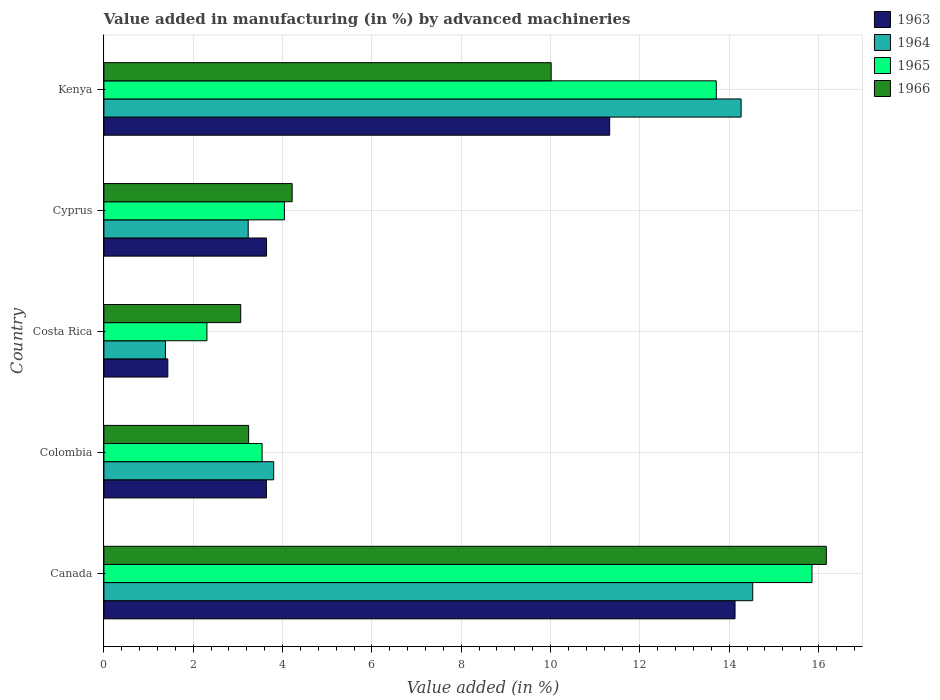How many different coloured bars are there?
Provide a short and direct response. 4. How many groups of bars are there?
Ensure brevity in your answer.  5. Are the number of bars on each tick of the Y-axis equal?
Provide a short and direct response. Yes. How many bars are there on the 3rd tick from the bottom?
Make the answer very short. 4. What is the percentage of value added in manufacturing by advanced machineries in 1964 in Cyprus?
Make the answer very short. 3.23. Across all countries, what is the maximum percentage of value added in manufacturing by advanced machineries in 1964?
Your answer should be compact. 14.53. Across all countries, what is the minimum percentage of value added in manufacturing by advanced machineries in 1966?
Your answer should be compact. 3.06. In which country was the percentage of value added in manufacturing by advanced machineries in 1966 minimum?
Provide a short and direct response. Costa Rica. What is the total percentage of value added in manufacturing by advanced machineries in 1964 in the graph?
Make the answer very short. 37.2. What is the difference between the percentage of value added in manufacturing by advanced machineries in 1963 in Canada and that in Costa Rica?
Your response must be concise. 12.7. What is the difference between the percentage of value added in manufacturing by advanced machineries in 1966 in Kenya and the percentage of value added in manufacturing by advanced machineries in 1963 in Cyprus?
Provide a succinct answer. 6.37. What is the average percentage of value added in manufacturing by advanced machineries in 1966 per country?
Make the answer very short. 7.34. What is the difference between the percentage of value added in manufacturing by advanced machineries in 1966 and percentage of value added in manufacturing by advanced machineries in 1965 in Kenya?
Keep it short and to the point. -3.7. In how many countries, is the percentage of value added in manufacturing by advanced machineries in 1965 greater than 11.6 %?
Your answer should be compact. 2. What is the ratio of the percentage of value added in manufacturing by advanced machineries in 1966 in Colombia to that in Costa Rica?
Ensure brevity in your answer.  1.06. What is the difference between the highest and the second highest percentage of value added in manufacturing by advanced machineries in 1964?
Keep it short and to the point. 0.26. What is the difference between the highest and the lowest percentage of value added in manufacturing by advanced machineries in 1966?
Offer a very short reply. 13.11. Is it the case that in every country, the sum of the percentage of value added in manufacturing by advanced machineries in 1963 and percentage of value added in manufacturing by advanced machineries in 1964 is greater than the sum of percentage of value added in manufacturing by advanced machineries in 1966 and percentage of value added in manufacturing by advanced machineries in 1965?
Keep it short and to the point. No. What does the 1st bar from the bottom in Costa Rica represents?
Your answer should be very brief. 1963. Is it the case that in every country, the sum of the percentage of value added in manufacturing by advanced machineries in 1965 and percentage of value added in manufacturing by advanced machineries in 1966 is greater than the percentage of value added in manufacturing by advanced machineries in 1963?
Offer a very short reply. Yes. How many bars are there?
Provide a succinct answer. 20. How many countries are there in the graph?
Keep it short and to the point. 5. Are the values on the major ticks of X-axis written in scientific E-notation?
Your response must be concise. No. Does the graph contain grids?
Provide a short and direct response. Yes. Where does the legend appear in the graph?
Keep it short and to the point. Top right. How are the legend labels stacked?
Give a very brief answer. Vertical. What is the title of the graph?
Keep it short and to the point. Value added in manufacturing (in %) by advanced machineries. What is the label or title of the X-axis?
Your answer should be compact. Value added (in %). What is the label or title of the Y-axis?
Keep it short and to the point. Country. What is the Value added (in %) of 1963 in Canada?
Provide a short and direct response. 14.13. What is the Value added (in %) in 1964 in Canada?
Your answer should be compact. 14.53. What is the Value added (in %) in 1965 in Canada?
Give a very brief answer. 15.85. What is the Value added (in %) in 1966 in Canada?
Your answer should be compact. 16.17. What is the Value added (in %) of 1963 in Colombia?
Ensure brevity in your answer.  3.64. What is the Value added (in %) of 1964 in Colombia?
Make the answer very short. 3.8. What is the Value added (in %) in 1965 in Colombia?
Your response must be concise. 3.54. What is the Value added (in %) of 1966 in Colombia?
Ensure brevity in your answer.  3.24. What is the Value added (in %) of 1963 in Costa Rica?
Provide a succinct answer. 1.43. What is the Value added (in %) of 1964 in Costa Rica?
Offer a very short reply. 1.38. What is the Value added (in %) of 1965 in Costa Rica?
Your answer should be very brief. 2.31. What is the Value added (in %) in 1966 in Costa Rica?
Provide a short and direct response. 3.06. What is the Value added (in %) of 1963 in Cyprus?
Keep it short and to the point. 3.64. What is the Value added (in %) in 1964 in Cyprus?
Ensure brevity in your answer.  3.23. What is the Value added (in %) in 1965 in Cyprus?
Make the answer very short. 4.04. What is the Value added (in %) of 1966 in Cyprus?
Your response must be concise. 4.22. What is the Value added (in %) of 1963 in Kenya?
Make the answer very short. 11.32. What is the Value added (in %) in 1964 in Kenya?
Your response must be concise. 14.27. What is the Value added (in %) in 1965 in Kenya?
Your answer should be very brief. 13.71. What is the Value added (in %) in 1966 in Kenya?
Offer a very short reply. 10.01. Across all countries, what is the maximum Value added (in %) of 1963?
Your response must be concise. 14.13. Across all countries, what is the maximum Value added (in %) in 1964?
Offer a terse response. 14.53. Across all countries, what is the maximum Value added (in %) of 1965?
Ensure brevity in your answer.  15.85. Across all countries, what is the maximum Value added (in %) in 1966?
Your response must be concise. 16.17. Across all countries, what is the minimum Value added (in %) in 1963?
Provide a short and direct response. 1.43. Across all countries, what is the minimum Value added (in %) in 1964?
Provide a short and direct response. 1.38. Across all countries, what is the minimum Value added (in %) of 1965?
Offer a terse response. 2.31. Across all countries, what is the minimum Value added (in %) of 1966?
Keep it short and to the point. 3.06. What is the total Value added (in %) of 1963 in the graph?
Your answer should be very brief. 34.16. What is the total Value added (in %) of 1964 in the graph?
Provide a succinct answer. 37.2. What is the total Value added (in %) of 1965 in the graph?
Provide a short and direct response. 39.45. What is the total Value added (in %) of 1966 in the graph?
Offer a terse response. 36.71. What is the difference between the Value added (in %) of 1963 in Canada and that in Colombia?
Provide a short and direct response. 10.49. What is the difference between the Value added (in %) of 1964 in Canada and that in Colombia?
Provide a short and direct response. 10.72. What is the difference between the Value added (in %) in 1965 in Canada and that in Colombia?
Offer a terse response. 12.31. What is the difference between the Value added (in %) of 1966 in Canada and that in Colombia?
Your response must be concise. 12.93. What is the difference between the Value added (in %) of 1963 in Canada and that in Costa Rica?
Keep it short and to the point. 12.7. What is the difference between the Value added (in %) of 1964 in Canada and that in Costa Rica?
Your answer should be compact. 13.15. What is the difference between the Value added (in %) in 1965 in Canada and that in Costa Rica?
Give a very brief answer. 13.55. What is the difference between the Value added (in %) of 1966 in Canada and that in Costa Rica?
Keep it short and to the point. 13.11. What is the difference between the Value added (in %) in 1963 in Canada and that in Cyprus?
Offer a very short reply. 10.49. What is the difference between the Value added (in %) of 1964 in Canada and that in Cyprus?
Your answer should be very brief. 11.3. What is the difference between the Value added (in %) of 1965 in Canada and that in Cyprus?
Give a very brief answer. 11.81. What is the difference between the Value added (in %) in 1966 in Canada and that in Cyprus?
Ensure brevity in your answer.  11.96. What is the difference between the Value added (in %) in 1963 in Canada and that in Kenya?
Your answer should be very brief. 2.81. What is the difference between the Value added (in %) in 1964 in Canada and that in Kenya?
Give a very brief answer. 0.26. What is the difference between the Value added (in %) in 1965 in Canada and that in Kenya?
Make the answer very short. 2.14. What is the difference between the Value added (in %) in 1966 in Canada and that in Kenya?
Offer a terse response. 6.16. What is the difference between the Value added (in %) in 1963 in Colombia and that in Costa Rica?
Ensure brevity in your answer.  2.21. What is the difference between the Value added (in %) in 1964 in Colombia and that in Costa Rica?
Ensure brevity in your answer.  2.42. What is the difference between the Value added (in %) in 1965 in Colombia and that in Costa Rica?
Your answer should be very brief. 1.24. What is the difference between the Value added (in %) in 1966 in Colombia and that in Costa Rica?
Make the answer very short. 0.18. What is the difference between the Value added (in %) of 1963 in Colombia and that in Cyprus?
Make the answer very short. -0. What is the difference between the Value added (in %) of 1964 in Colombia and that in Cyprus?
Offer a terse response. 0.57. What is the difference between the Value added (in %) in 1965 in Colombia and that in Cyprus?
Offer a terse response. -0.5. What is the difference between the Value added (in %) in 1966 in Colombia and that in Cyprus?
Your answer should be very brief. -0.97. What is the difference between the Value added (in %) of 1963 in Colombia and that in Kenya?
Offer a terse response. -7.69. What is the difference between the Value added (in %) of 1964 in Colombia and that in Kenya?
Ensure brevity in your answer.  -10.47. What is the difference between the Value added (in %) in 1965 in Colombia and that in Kenya?
Make the answer very short. -10.17. What is the difference between the Value added (in %) of 1966 in Colombia and that in Kenya?
Offer a terse response. -6.77. What is the difference between the Value added (in %) of 1963 in Costa Rica and that in Cyprus?
Ensure brevity in your answer.  -2.21. What is the difference between the Value added (in %) of 1964 in Costa Rica and that in Cyprus?
Offer a very short reply. -1.85. What is the difference between the Value added (in %) in 1965 in Costa Rica and that in Cyprus?
Give a very brief answer. -1.73. What is the difference between the Value added (in %) of 1966 in Costa Rica and that in Cyprus?
Offer a terse response. -1.15. What is the difference between the Value added (in %) of 1963 in Costa Rica and that in Kenya?
Make the answer very short. -9.89. What is the difference between the Value added (in %) of 1964 in Costa Rica and that in Kenya?
Ensure brevity in your answer.  -12.89. What is the difference between the Value added (in %) of 1965 in Costa Rica and that in Kenya?
Offer a very short reply. -11.4. What is the difference between the Value added (in %) in 1966 in Costa Rica and that in Kenya?
Keep it short and to the point. -6.95. What is the difference between the Value added (in %) of 1963 in Cyprus and that in Kenya?
Your answer should be compact. -7.68. What is the difference between the Value added (in %) in 1964 in Cyprus and that in Kenya?
Keep it short and to the point. -11.04. What is the difference between the Value added (in %) of 1965 in Cyprus and that in Kenya?
Provide a short and direct response. -9.67. What is the difference between the Value added (in %) in 1966 in Cyprus and that in Kenya?
Your response must be concise. -5.8. What is the difference between the Value added (in %) in 1963 in Canada and the Value added (in %) in 1964 in Colombia?
Keep it short and to the point. 10.33. What is the difference between the Value added (in %) in 1963 in Canada and the Value added (in %) in 1965 in Colombia?
Provide a short and direct response. 10.59. What is the difference between the Value added (in %) of 1963 in Canada and the Value added (in %) of 1966 in Colombia?
Ensure brevity in your answer.  10.89. What is the difference between the Value added (in %) in 1964 in Canada and the Value added (in %) in 1965 in Colombia?
Offer a terse response. 10.98. What is the difference between the Value added (in %) of 1964 in Canada and the Value added (in %) of 1966 in Colombia?
Make the answer very short. 11.29. What is the difference between the Value added (in %) in 1965 in Canada and the Value added (in %) in 1966 in Colombia?
Provide a short and direct response. 12.61. What is the difference between the Value added (in %) of 1963 in Canada and the Value added (in %) of 1964 in Costa Rica?
Ensure brevity in your answer.  12.75. What is the difference between the Value added (in %) of 1963 in Canada and the Value added (in %) of 1965 in Costa Rica?
Your answer should be very brief. 11.82. What is the difference between the Value added (in %) in 1963 in Canada and the Value added (in %) in 1966 in Costa Rica?
Keep it short and to the point. 11.07. What is the difference between the Value added (in %) in 1964 in Canada and the Value added (in %) in 1965 in Costa Rica?
Your answer should be compact. 12.22. What is the difference between the Value added (in %) of 1964 in Canada and the Value added (in %) of 1966 in Costa Rica?
Ensure brevity in your answer.  11.46. What is the difference between the Value added (in %) of 1965 in Canada and the Value added (in %) of 1966 in Costa Rica?
Provide a short and direct response. 12.79. What is the difference between the Value added (in %) in 1963 in Canada and the Value added (in %) in 1964 in Cyprus?
Provide a short and direct response. 10.9. What is the difference between the Value added (in %) of 1963 in Canada and the Value added (in %) of 1965 in Cyprus?
Offer a terse response. 10.09. What is the difference between the Value added (in %) in 1963 in Canada and the Value added (in %) in 1966 in Cyprus?
Ensure brevity in your answer.  9.92. What is the difference between the Value added (in %) of 1964 in Canada and the Value added (in %) of 1965 in Cyprus?
Give a very brief answer. 10.49. What is the difference between the Value added (in %) in 1964 in Canada and the Value added (in %) in 1966 in Cyprus?
Your answer should be compact. 10.31. What is the difference between the Value added (in %) in 1965 in Canada and the Value added (in %) in 1966 in Cyprus?
Ensure brevity in your answer.  11.64. What is the difference between the Value added (in %) in 1963 in Canada and the Value added (in %) in 1964 in Kenya?
Offer a terse response. -0.14. What is the difference between the Value added (in %) in 1963 in Canada and the Value added (in %) in 1965 in Kenya?
Offer a terse response. 0.42. What is the difference between the Value added (in %) in 1963 in Canada and the Value added (in %) in 1966 in Kenya?
Offer a very short reply. 4.12. What is the difference between the Value added (in %) in 1964 in Canada and the Value added (in %) in 1965 in Kenya?
Ensure brevity in your answer.  0.82. What is the difference between the Value added (in %) of 1964 in Canada and the Value added (in %) of 1966 in Kenya?
Provide a short and direct response. 4.51. What is the difference between the Value added (in %) in 1965 in Canada and the Value added (in %) in 1966 in Kenya?
Provide a succinct answer. 5.84. What is the difference between the Value added (in %) in 1963 in Colombia and the Value added (in %) in 1964 in Costa Rica?
Keep it short and to the point. 2.26. What is the difference between the Value added (in %) in 1963 in Colombia and the Value added (in %) in 1965 in Costa Rica?
Offer a terse response. 1.33. What is the difference between the Value added (in %) of 1963 in Colombia and the Value added (in %) of 1966 in Costa Rica?
Your response must be concise. 0.57. What is the difference between the Value added (in %) of 1964 in Colombia and the Value added (in %) of 1965 in Costa Rica?
Offer a terse response. 1.49. What is the difference between the Value added (in %) in 1964 in Colombia and the Value added (in %) in 1966 in Costa Rica?
Provide a succinct answer. 0.74. What is the difference between the Value added (in %) of 1965 in Colombia and the Value added (in %) of 1966 in Costa Rica?
Your answer should be compact. 0.48. What is the difference between the Value added (in %) in 1963 in Colombia and the Value added (in %) in 1964 in Cyprus?
Make the answer very short. 0.41. What is the difference between the Value added (in %) in 1963 in Colombia and the Value added (in %) in 1965 in Cyprus?
Keep it short and to the point. -0.4. What is the difference between the Value added (in %) in 1963 in Colombia and the Value added (in %) in 1966 in Cyprus?
Keep it short and to the point. -0.58. What is the difference between the Value added (in %) of 1964 in Colombia and the Value added (in %) of 1965 in Cyprus?
Make the answer very short. -0.24. What is the difference between the Value added (in %) in 1964 in Colombia and the Value added (in %) in 1966 in Cyprus?
Offer a very short reply. -0.41. What is the difference between the Value added (in %) of 1965 in Colombia and the Value added (in %) of 1966 in Cyprus?
Offer a terse response. -0.67. What is the difference between the Value added (in %) in 1963 in Colombia and the Value added (in %) in 1964 in Kenya?
Offer a terse response. -10.63. What is the difference between the Value added (in %) of 1963 in Colombia and the Value added (in %) of 1965 in Kenya?
Provide a short and direct response. -10.07. What is the difference between the Value added (in %) in 1963 in Colombia and the Value added (in %) in 1966 in Kenya?
Offer a terse response. -6.38. What is the difference between the Value added (in %) in 1964 in Colombia and the Value added (in %) in 1965 in Kenya?
Ensure brevity in your answer.  -9.91. What is the difference between the Value added (in %) in 1964 in Colombia and the Value added (in %) in 1966 in Kenya?
Provide a short and direct response. -6.21. What is the difference between the Value added (in %) of 1965 in Colombia and the Value added (in %) of 1966 in Kenya?
Your answer should be compact. -6.47. What is the difference between the Value added (in %) of 1963 in Costa Rica and the Value added (in %) of 1964 in Cyprus?
Your response must be concise. -1.8. What is the difference between the Value added (in %) in 1963 in Costa Rica and the Value added (in %) in 1965 in Cyprus?
Ensure brevity in your answer.  -2.61. What is the difference between the Value added (in %) of 1963 in Costa Rica and the Value added (in %) of 1966 in Cyprus?
Offer a very short reply. -2.78. What is the difference between the Value added (in %) of 1964 in Costa Rica and the Value added (in %) of 1965 in Cyprus?
Keep it short and to the point. -2.66. What is the difference between the Value added (in %) in 1964 in Costa Rica and the Value added (in %) in 1966 in Cyprus?
Your answer should be very brief. -2.84. What is the difference between the Value added (in %) in 1965 in Costa Rica and the Value added (in %) in 1966 in Cyprus?
Provide a succinct answer. -1.91. What is the difference between the Value added (in %) of 1963 in Costa Rica and the Value added (in %) of 1964 in Kenya?
Provide a succinct answer. -12.84. What is the difference between the Value added (in %) in 1963 in Costa Rica and the Value added (in %) in 1965 in Kenya?
Ensure brevity in your answer.  -12.28. What is the difference between the Value added (in %) in 1963 in Costa Rica and the Value added (in %) in 1966 in Kenya?
Make the answer very short. -8.58. What is the difference between the Value added (in %) in 1964 in Costa Rica and the Value added (in %) in 1965 in Kenya?
Provide a short and direct response. -12.33. What is the difference between the Value added (in %) in 1964 in Costa Rica and the Value added (in %) in 1966 in Kenya?
Provide a short and direct response. -8.64. What is the difference between the Value added (in %) in 1965 in Costa Rica and the Value added (in %) in 1966 in Kenya?
Keep it short and to the point. -7.71. What is the difference between the Value added (in %) of 1963 in Cyprus and the Value added (in %) of 1964 in Kenya?
Your response must be concise. -10.63. What is the difference between the Value added (in %) of 1963 in Cyprus and the Value added (in %) of 1965 in Kenya?
Keep it short and to the point. -10.07. What is the difference between the Value added (in %) of 1963 in Cyprus and the Value added (in %) of 1966 in Kenya?
Offer a terse response. -6.37. What is the difference between the Value added (in %) of 1964 in Cyprus and the Value added (in %) of 1965 in Kenya?
Offer a very short reply. -10.48. What is the difference between the Value added (in %) in 1964 in Cyprus and the Value added (in %) in 1966 in Kenya?
Provide a short and direct response. -6.78. What is the difference between the Value added (in %) in 1965 in Cyprus and the Value added (in %) in 1966 in Kenya?
Keep it short and to the point. -5.97. What is the average Value added (in %) of 1963 per country?
Your answer should be very brief. 6.83. What is the average Value added (in %) of 1964 per country?
Make the answer very short. 7.44. What is the average Value added (in %) in 1965 per country?
Provide a succinct answer. 7.89. What is the average Value added (in %) of 1966 per country?
Make the answer very short. 7.34. What is the difference between the Value added (in %) in 1963 and Value added (in %) in 1964 in Canada?
Offer a terse response. -0.4. What is the difference between the Value added (in %) in 1963 and Value added (in %) in 1965 in Canada?
Provide a succinct answer. -1.72. What is the difference between the Value added (in %) of 1963 and Value added (in %) of 1966 in Canada?
Provide a succinct answer. -2.04. What is the difference between the Value added (in %) in 1964 and Value added (in %) in 1965 in Canada?
Ensure brevity in your answer.  -1.33. What is the difference between the Value added (in %) in 1964 and Value added (in %) in 1966 in Canada?
Keep it short and to the point. -1.65. What is the difference between the Value added (in %) in 1965 and Value added (in %) in 1966 in Canada?
Keep it short and to the point. -0.32. What is the difference between the Value added (in %) of 1963 and Value added (in %) of 1964 in Colombia?
Your response must be concise. -0.16. What is the difference between the Value added (in %) in 1963 and Value added (in %) in 1965 in Colombia?
Provide a succinct answer. 0.1. What is the difference between the Value added (in %) of 1963 and Value added (in %) of 1966 in Colombia?
Offer a terse response. 0.4. What is the difference between the Value added (in %) of 1964 and Value added (in %) of 1965 in Colombia?
Your response must be concise. 0.26. What is the difference between the Value added (in %) in 1964 and Value added (in %) in 1966 in Colombia?
Your response must be concise. 0.56. What is the difference between the Value added (in %) in 1965 and Value added (in %) in 1966 in Colombia?
Your answer should be compact. 0.3. What is the difference between the Value added (in %) of 1963 and Value added (in %) of 1964 in Costa Rica?
Give a very brief answer. 0.05. What is the difference between the Value added (in %) in 1963 and Value added (in %) in 1965 in Costa Rica?
Your answer should be very brief. -0.88. What is the difference between the Value added (in %) in 1963 and Value added (in %) in 1966 in Costa Rica?
Ensure brevity in your answer.  -1.63. What is the difference between the Value added (in %) in 1964 and Value added (in %) in 1965 in Costa Rica?
Offer a terse response. -0.93. What is the difference between the Value added (in %) in 1964 and Value added (in %) in 1966 in Costa Rica?
Your answer should be very brief. -1.69. What is the difference between the Value added (in %) of 1965 and Value added (in %) of 1966 in Costa Rica?
Ensure brevity in your answer.  -0.76. What is the difference between the Value added (in %) in 1963 and Value added (in %) in 1964 in Cyprus?
Provide a short and direct response. 0.41. What is the difference between the Value added (in %) in 1963 and Value added (in %) in 1965 in Cyprus?
Your answer should be compact. -0.4. What is the difference between the Value added (in %) in 1963 and Value added (in %) in 1966 in Cyprus?
Your answer should be compact. -0.57. What is the difference between the Value added (in %) of 1964 and Value added (in %) of 1965 in Cyprus?
Your answer should be compact. -0.81. What is the difference between the Value added (in %) of 1964 and Value added (in %) of 1966 in Cyprus?
Ensure brevity in your answer.  -0.98. What is the difference between the Value added (in %) in 1965 and Value added (in %) in 1966 in Cyprus?
Offer a terse response. -0.17. What is the difference between the Value added (in %) in 1963 and Value added (in %) in 1964 in Kenya?
Offer a terse response. -2.94. What is the difference between the Value added (in %) of 1963 and Value added (in %) of 1965 in Kenya?
Your answer should be compact. -2.39. What is the difference between the Value added (in %) of 1963 and Value added (in %) of 1966 in Kenya?
Provide a short and direct response. 1.31. What is the difference between the Value added (in %) of 1964 and Value added (in %) of 1965 in Kenya?
Your response must be concise. 0.56. What is the difference between the Value added (in %) in 1964 and Value added (in %) in 1966 in Kenya?
Ensure brevity in your answer.  4.25. What is the difference between the Value added (in %) in 1965 and Value added (in %) in 1966 in Kenya?
Your answer should be very brief. 3.7. What is the ratio of the Value added (in %) in 1963 in Canada to that in Colombia?
Provide a short and direct response. 3.88. What is the ratio of the Value added (in %) of 1964 in Canada to that in Colombia?
Keep it short and to the point. 3.82. What is the ratio of the Value added (in %) in 1965 in Canada to that in Colombia?
Your answer should be very brief. 4.48. What is the ratio of the Value added (in %) in 1966 in Canada to that in Colombia?
Offer a terse response. 4.99. What is the ratio of the Value added (in %) of 1963 in Canada to that in Costa Rica?
Offer a very short reply. 9.87. What is the ratio of the Value added (in %) of 1964 in Canada to that in Costa Rica?
Keep it short and to the point. 10.54. What is the ratio of the Value added (in %) of 1965 in Canada to that in Costa Rica?
Offer a terse response. 6.87. What is the ratio of the Value added (in %) of 1966 in Canada to that in Costa Rica?
Offer a very short reply. 5.28. What is the ratio of the Value added (in %) in 1963 in Canada to that in Cyprus?
Your response must be concise. 3.88. What is the ratio of the Value added (in %) in 1964 in Canada to that in Cyprus?
Provide a short and direct response. 4.5. What is the ratio of the Value added (in %) of 1965 in Canada to that in Cyprus?
Your answer should be very brief. 3.92. What is the ratio of the Value added (in %) of 1966 in Canada to that in Cyprus?
Make the answer very short. 3.84. What is the ratio of the Value added (in %) of 1963 in Canada to that in Kenya?
Offer a very short reply. 1.25. What is the ratio of the Value added (in %) of 1964 in Canada to that in Kenya?
Offer a terse response. 1.02. What is the ratio of the Value added (in %) in 1965 in Canada to that in Kenya?
Provide a succinct answer. 1.16. What is the ratio of the Value added (in %) of 1966 in Canada to that in Kenya?
Keep it short and to the point. 1.62. What is the ratio of the Value added (in %) of 1963 in Colombia to that in Costa Rica?
Provide a short and direct response. 2.54. What is the ratio of the Value added (in %) in 1964 in Colombia to that in Costa Rica?
Make the answer very short. 2.76. What is the ratio of the Value added (in %) in 1965 in Colombia to that in Costa Rica?
Provide a succinct answer. 1.54. What is the ratio of the Value added (in %) of 1966 in Colombia to that in Costa Rica?
Ensure brevity in your answer.  1.06. What is the ratio of the Value added (in %) in 1963 in Colombia to that in Cyprus?
Ensure brevity in your answer.  1. What is the ratio of the Value added (in %) of 1964 in Colombia to that in Cyprus?
Offer a terse response. 1.18. What is the ratio of the Value added (in %) of 1965 in Colombia to that in Cyprus?
Your answer should be very brief. 0.88. What is the ratio of the Value added (in %) of 1966 in Colombia to that in Cyprus?
Keep it short and to the point. 0.77. What is the ratio of the Value added (in %) in 1963 in Colombia to that in Kenya?
Offer a terse response. 0.32. What is the ratio of the Value added (in %) in 1964 in Colombia to that in Kenya?
Make the answer very short. 0.27. What is the ratio of the Value added (in %) in 1965 in Colombia to that in Kenya?
Offer a terse response. 0.26. What is the ratio of the Value added (in %) in 1966 in Colombia to that in Kenya?
Offer a terse response. 0.32. What is the ratio of the Value added (in %) of 1963 in Costa Rica to that in Cyprus?
Offer a very short reply. 0.39. What is the ratio of the Value added (in %) of 1964 in Costa Rica to that in Cyprus?
Your answer should be very brief. 0.43. What is the ratio of the Value added (in %) in 1965 in Costa Rica to that in Cyprus?
Provide a short and direct response. 0.57. What is the ratio of the Value added (in %) of 1966 in Costa Rica to that in Cyprus?
Your answer should be very brief. 0.73. What is the ratio of the Value added (in %) of 1963 in Costa Rica to that in Kenya?
Offer a terse response. 0.13. What is the ratio of the Value added (in %) in 1964 in Costa Rica to that in Kenya?
Your response must be concise. 0.1. What is the ratio of the Value added (in %) of 1965 in Costa Rica to that in Kenya?
Offer a terse response. 0.17. What is the ratio of the Value added (in %) of 1966 in Costa Rica to that in Kenya?
Make the answer very short. 0.31. What is the ratio of the Value added (in %) in 1963 in Cyprus to that in Kenya?
Offer a very short reply. 0.32. What is the ratio of the Value added (in %) in 1964 in Cyprus to that in Kenya?
Keep it short and to the point. 0.23. What is the ratio of the Value added (in %) of 1965 in Cyprus to that in Kenya?
Your response must be concise. 0.29. What is the ratio of the Value added (in %) in 1966 in Cyprus to that in Kenya?
Your answer should be compact. 0.42. What is the difference between the highest and the second highest Value added (in %) in 1963?
Your answer should be compact. 2.81. What is the difference between the highest and the second highest Value added (in %) of 1964?
Give a very brief answer. 0.26. What is the difference between the highest and the second highest Value added (in %) of 1965?
Offer a very short reply. 2.14. What is the difference between the highest and the second highest Value added (in %) of 1966?
Your answer should be compact. 6.16. What is the difference between the highest and the lowest Value added (in %) in 1963?
Your answer should be very brief. 12.7. What is the difference between the highest and the lowest Value added (in %) in 1964?
Your answer should be very brief. 13.15. What is the difference between the highest and the lowest Value added (in %) in 1965?
Your answer should be compact. 13.55. What is the difference between the highest and the lowest Value added (in %) of 1966?
Your response must be concise. 13.11. 